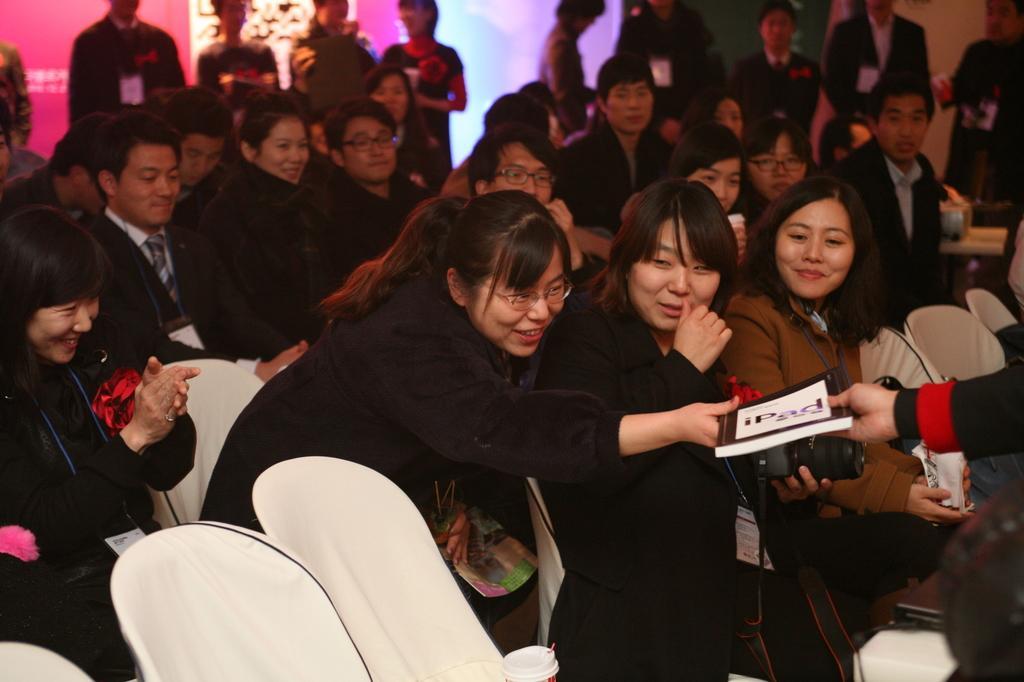Can you describe this image briefly? In this image we can see few people sitting on the chairs, some of them are standing, two of them are holding a book, a person is holding a camera and a person is holding an object. 